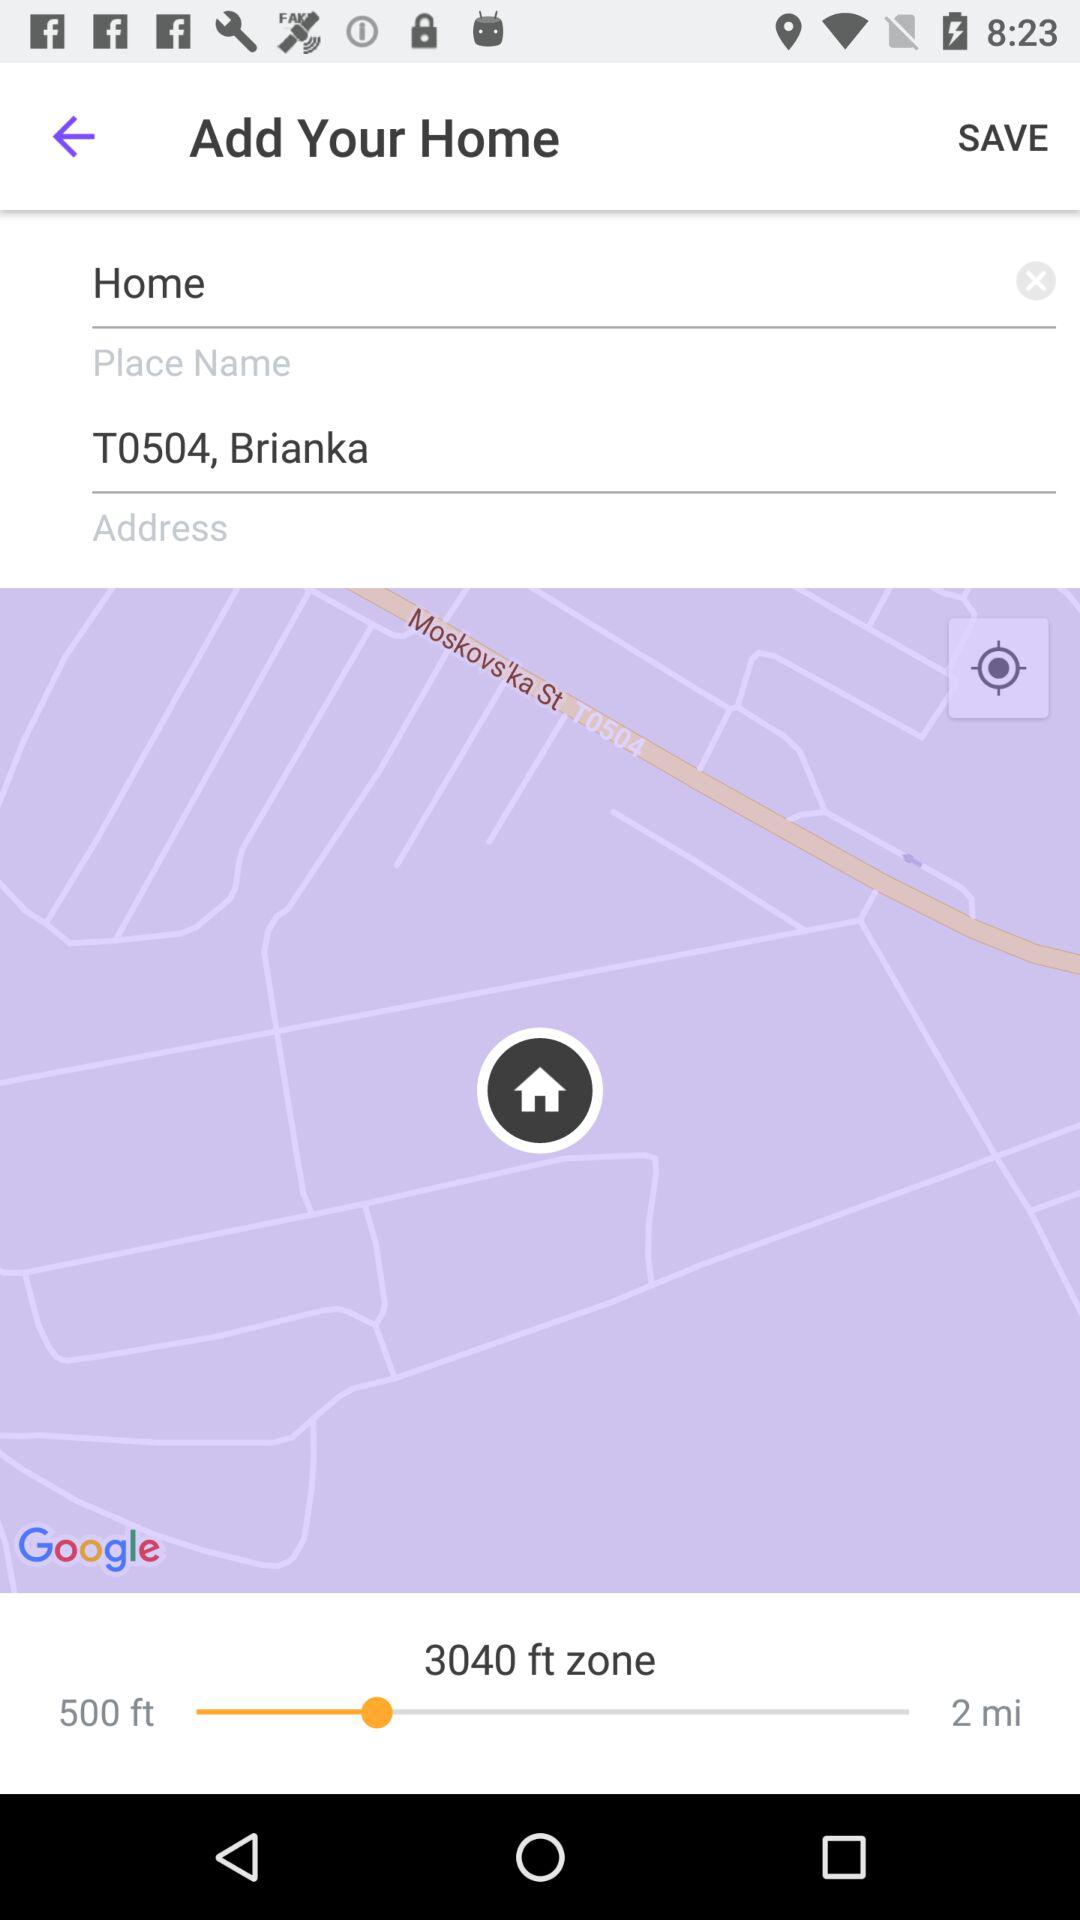What is the address? The address is T0504, Brianka. 